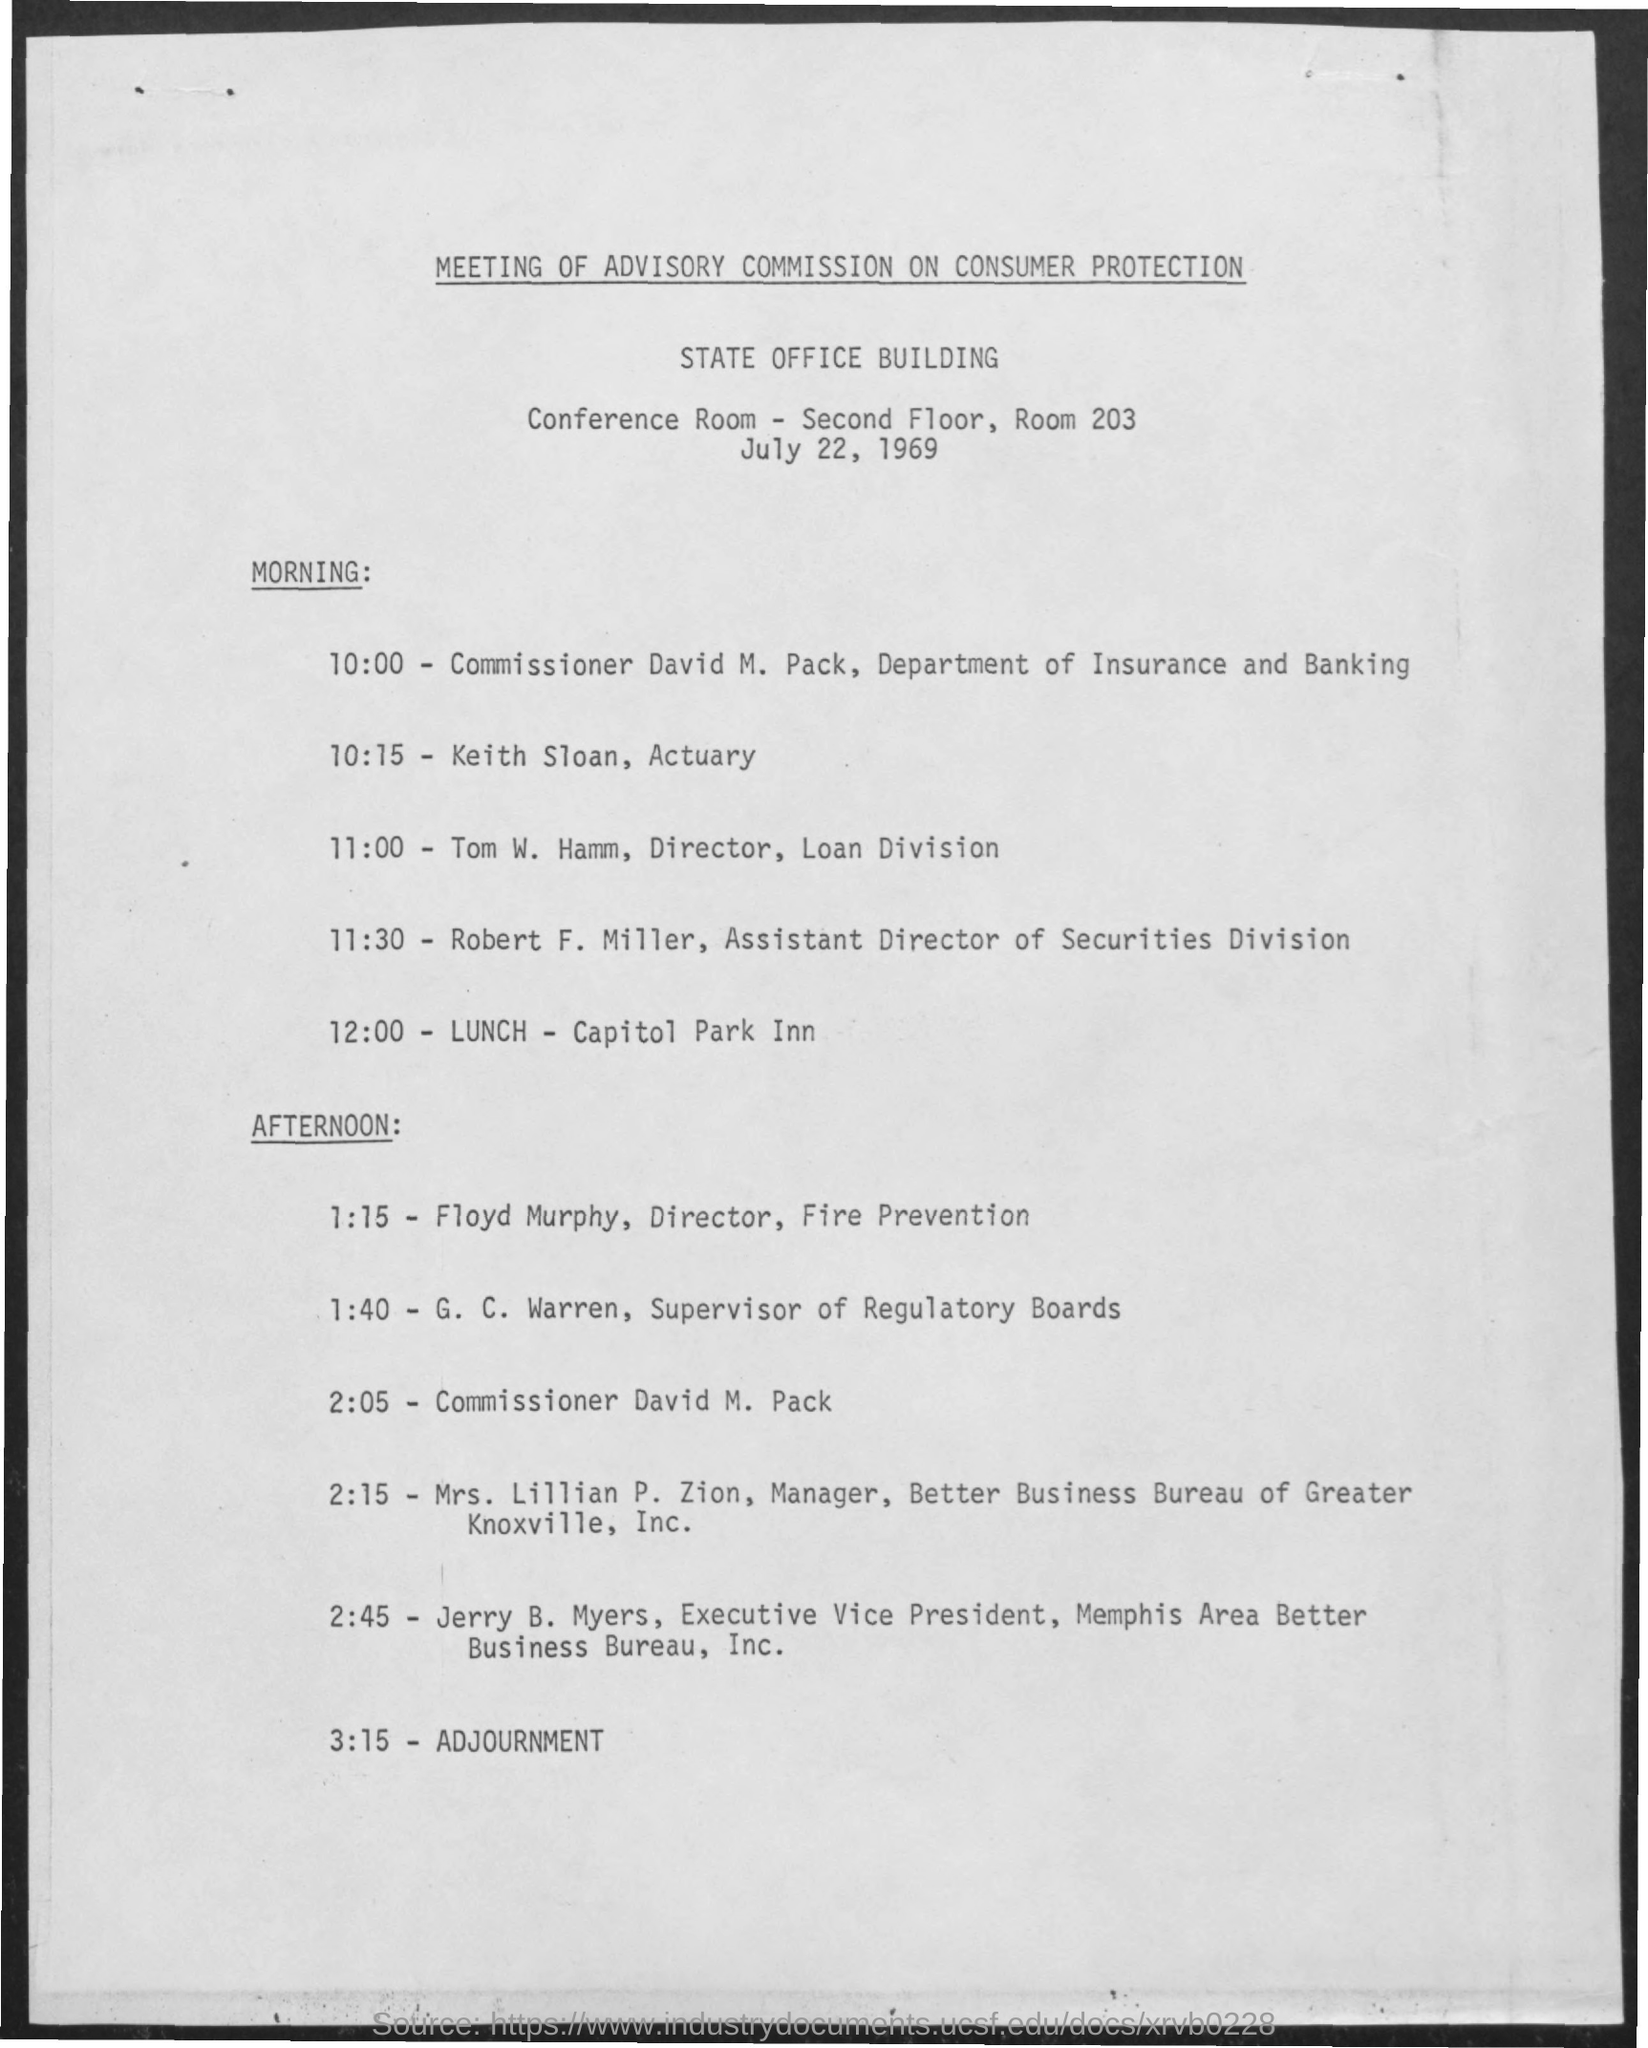Mention a couple of crucial points in this snapshot. The lunch time is 12:00. David M. Pack is the commissioner. The venue for lunch is the Capital Park Inn. The time of adjournment is 3:15. Floyd Murphy is the director of fire prevention. 